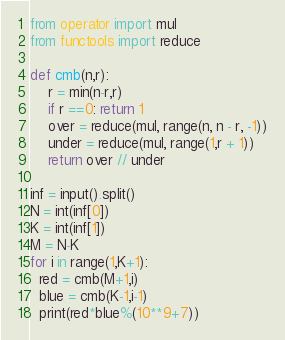<code> <loc_0><loc_0><loc_500><loc_500><_Python_>from operator import mul
from functools import reduce
 
def cmb(n,r):
    r = min(n-r,r)
    if r ==0: return 1
    over = reduce(mul, range(n, n - r, -1))
    under = reduce(mul, range(1,r + 1))
    return over // under

inf = input().split()
N = int(inf[0])
K = int(inf[1])
M = N-K
for i in range(1,K+1):
  red = cmb(M+1,i)
  blue = cmb(K-1,i-1)
  print(red*blue%(10**9+7))
</code> 